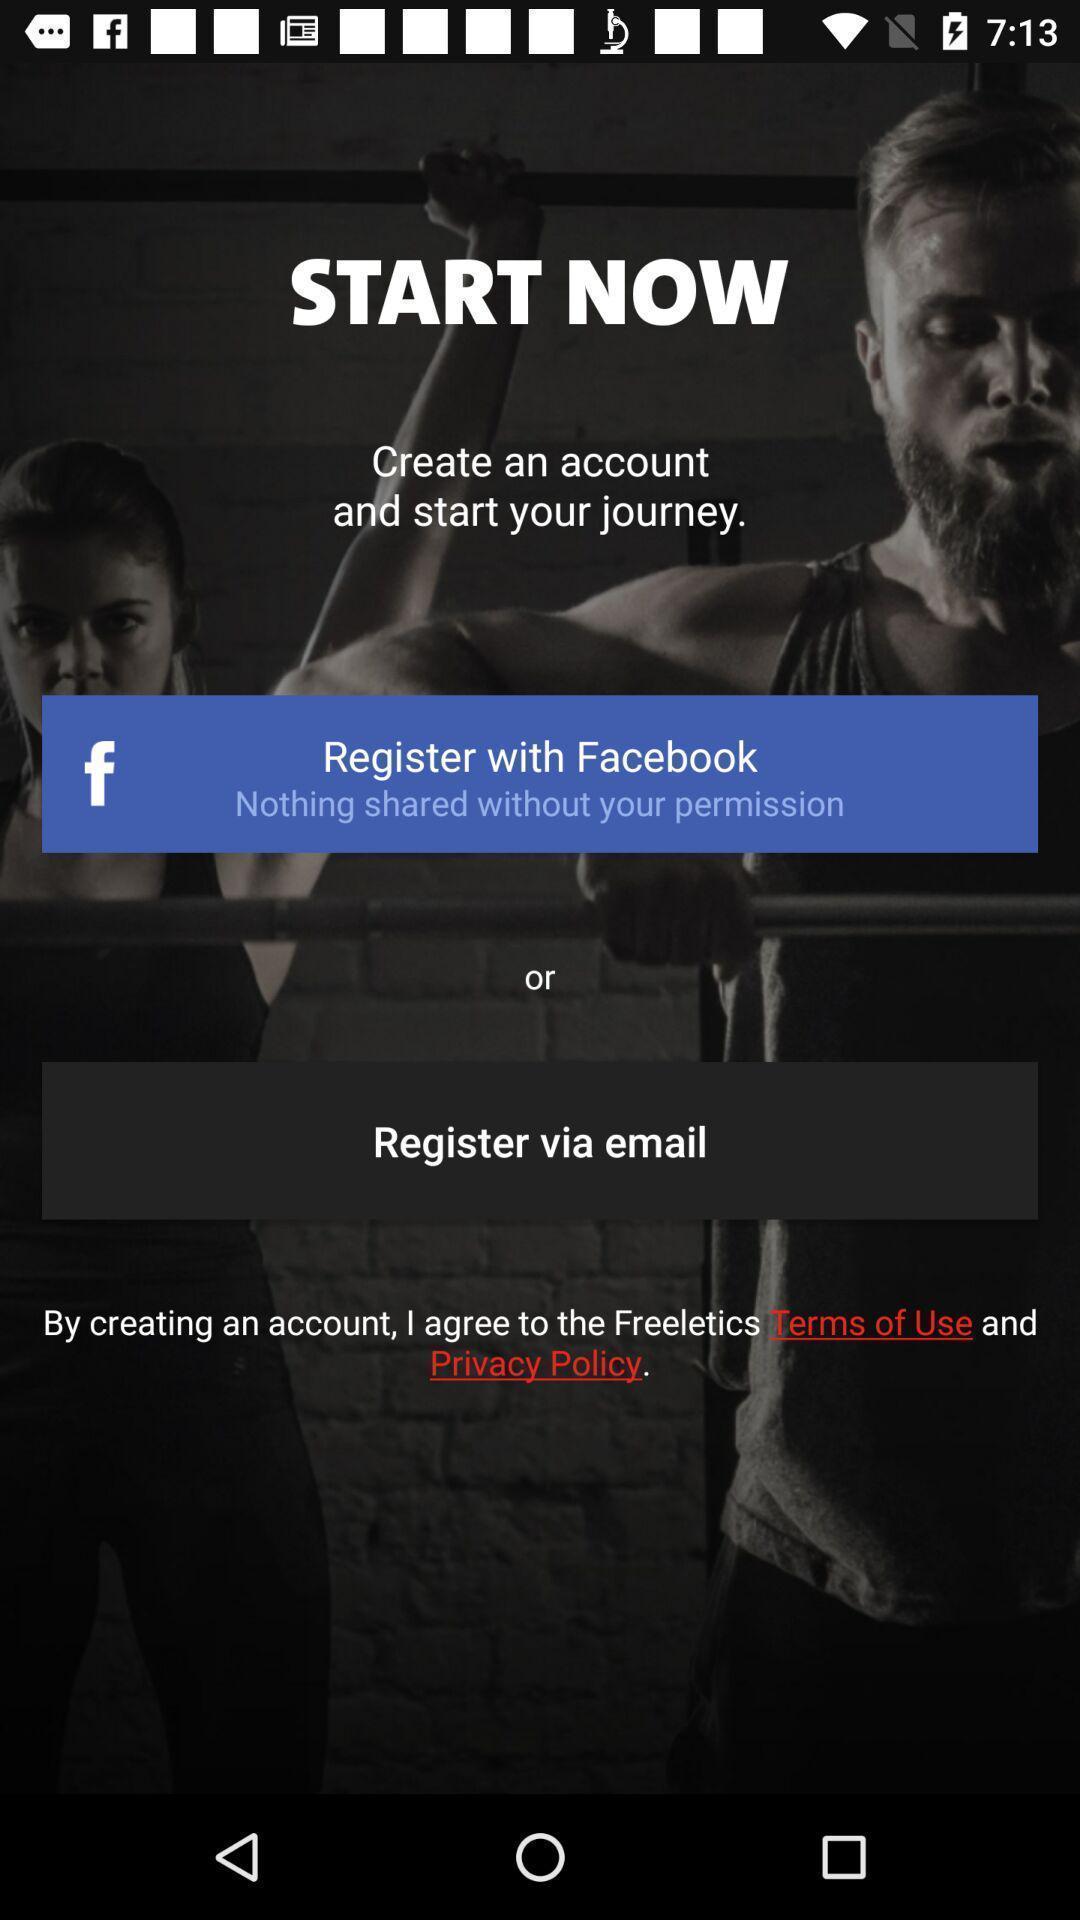Provide a detailed account of this screenshot. Start page of a fitness app. 